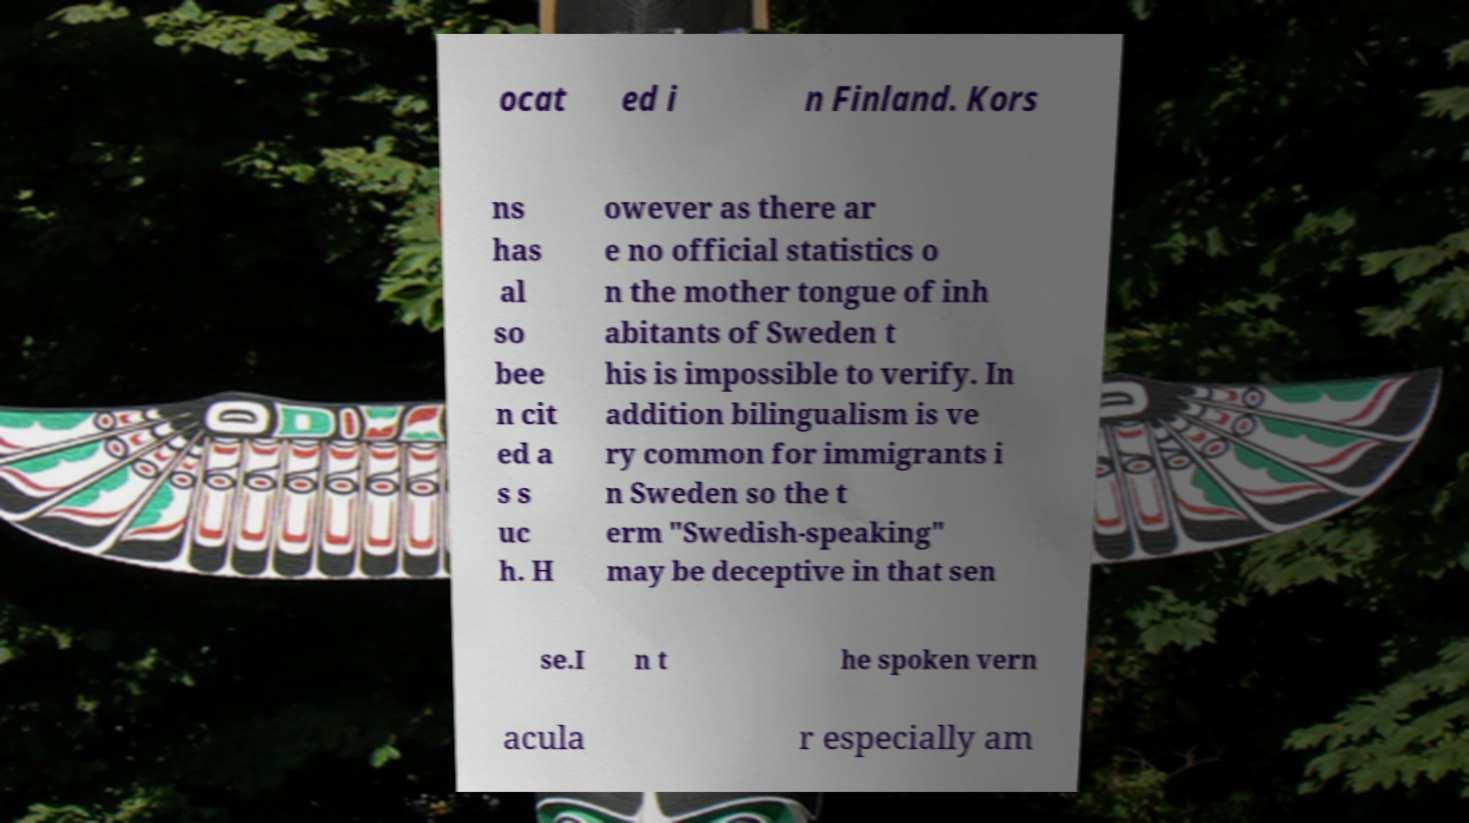Please identify and transcribe the text found in this image. ocat ed i n Finland. Kors ns has al so bee n cit ed a s s uc h. H owever as there ar e no official statistics o n the mother tongue of inh abitants of Sweden t his is impossible to verify. In addition bilingualism is ve ry common for immigrants i n Sweden so the t erm "Swedish-speaking" may be deceptive in that sen se.I n t he spoken vern acula r especially am 